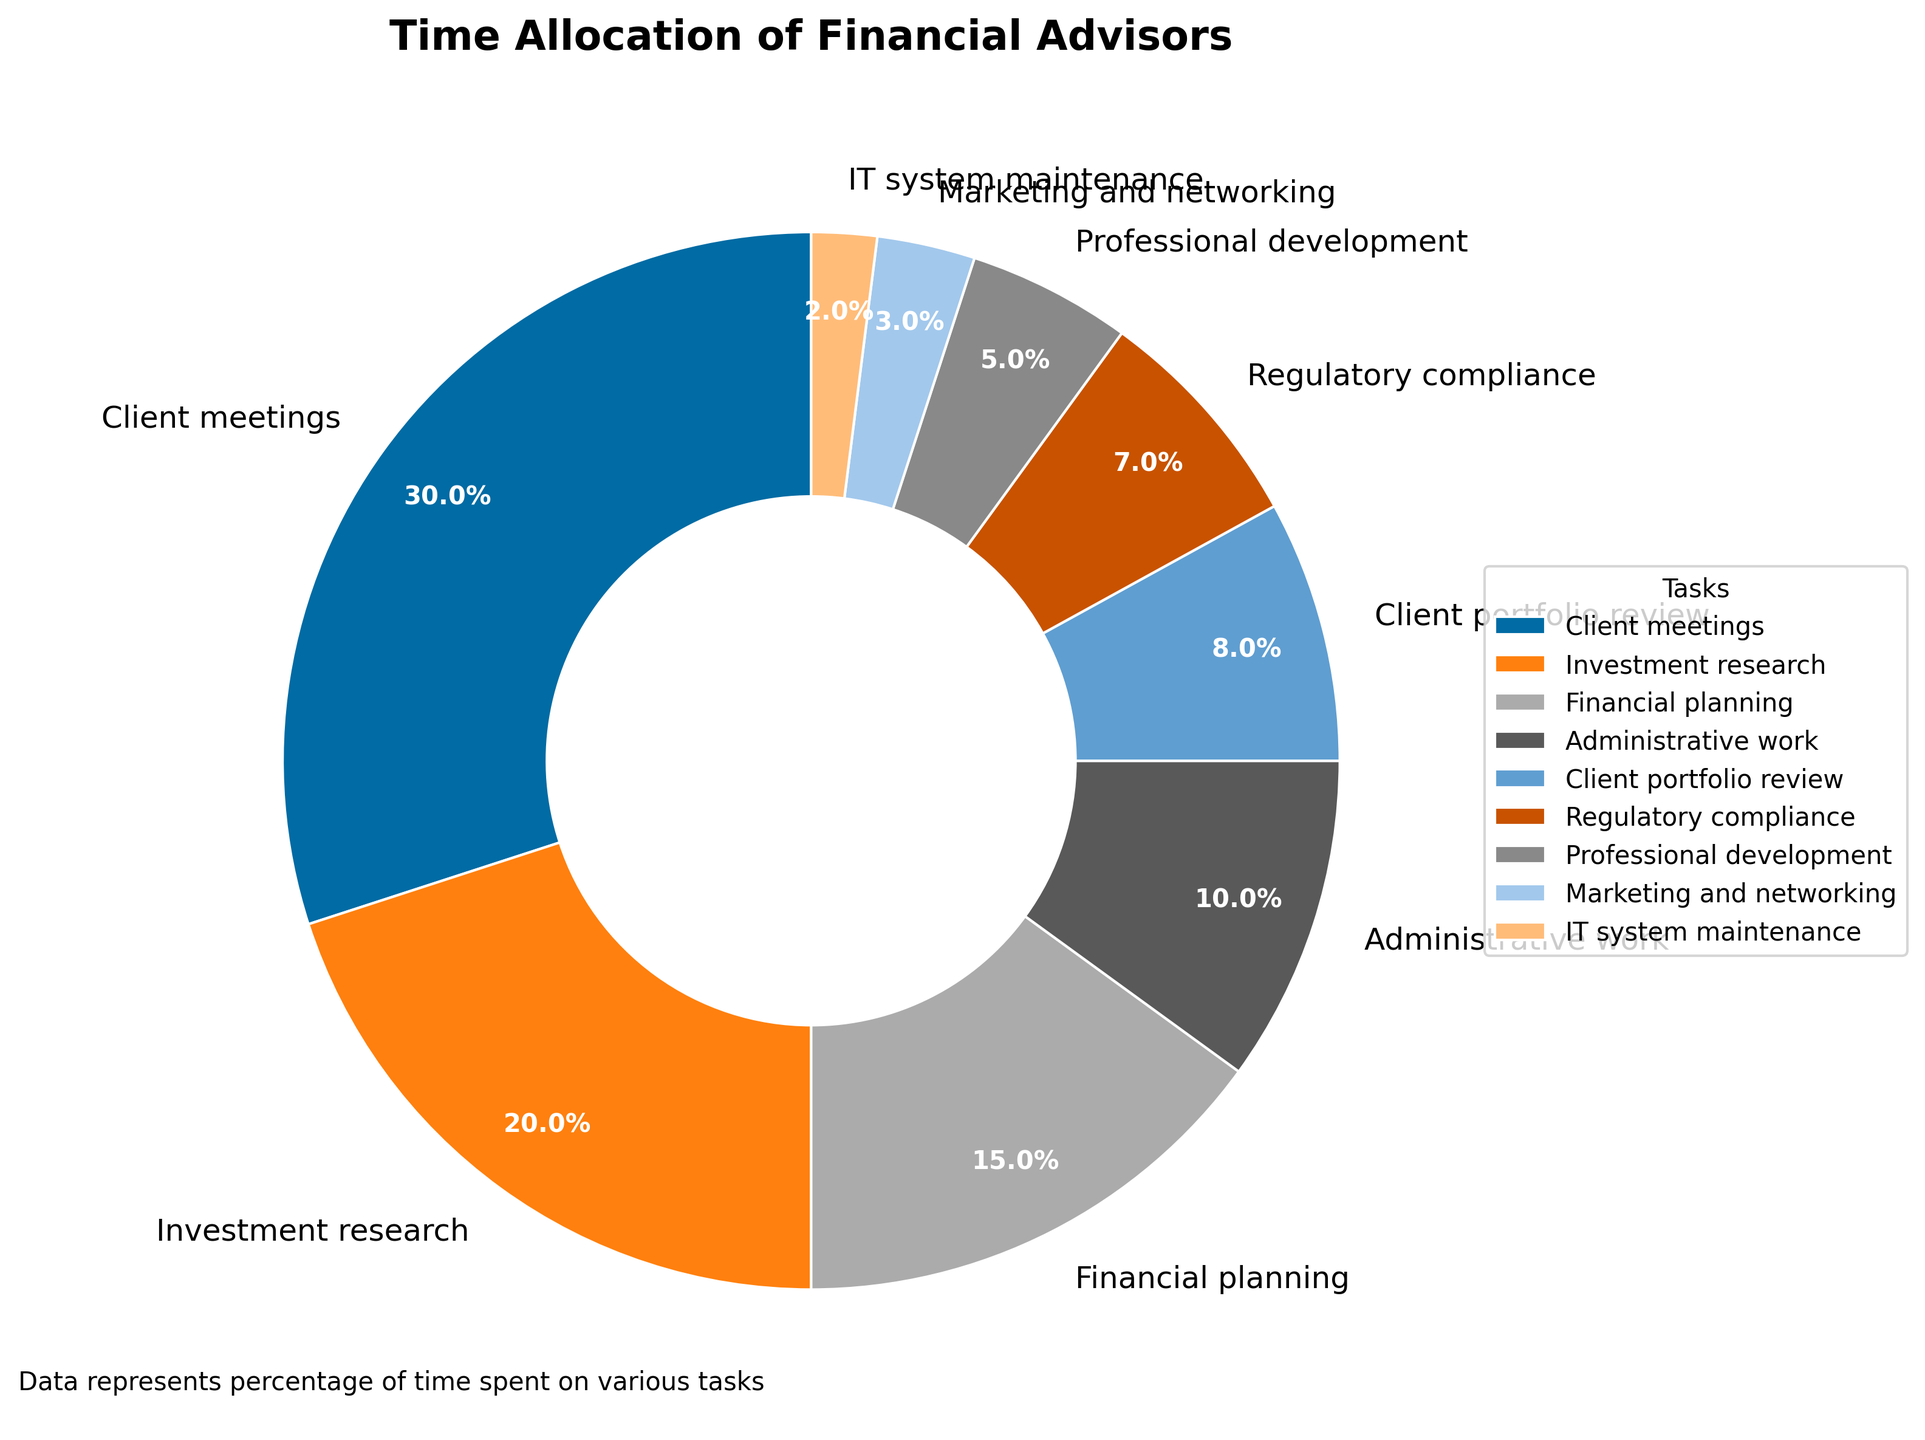What percentage of time is allocated to client meetings? Locate the "Client meetings" segment on the pie chart, which shows the percentage value inside it.
Answer: 30% How much more time is spent on client meetings compared to administrative work? Find the percentages for "Client meetings" (30%) and "Administrative work" (10%). Subtract the smaller from the larger (30% - 10%).
Answer: 20% Which task takes up the least amount of time? Identify the smallest segment on the pie chart. The smallest segment is for "IT system maintenance".
Answer: IT system maintenance What is the combined percentage of time spent on investment research and financial planning? Find the percentages for "Investment research" (20%) and "Financial planning" (15%). Add them together (20% + 15%).
Answer: 35% How does the time allocated to marketing and networking compare to time spent on regulatory compliance? Find the percentages for "Marketing and networking" (3%) and "Regulatory compliance" (7%). Compare the two values. 7% is greater than 3%.
Answer: Regulatory compliance is more Which task occupies a greater percentage of time: client portfolio review or professional development? Locate the segments for "Client portfolio review" (8%) and "Professional development" (5%). Compare the two values—8% is greater than 5%.
Answer: Client portfolio review What is the difference in time allocation between the most and least time-consuming tasks? The most time-consuming task is "Client meetings" (30%) and the least is "IT system maintenance" (2%). Subtract the smallest from the largest (30% - 2%).
Answer: 28% What tasks form the middle tier in terms of time allocation? Order tasks by percentage and find the middle. Middle tasks are "Financial planning" (15%), "Administrative work" (10%), and "Client portfolio review" (8%).
Answer: Financial planning, Administrative work, Client portfolio review If you combine time spent on administrative work and IT system maintenance, does it exceed the time spent on professional development? Find the percentages for "Administrative work" (10%) and "IT system maintenance" (2%). Add them (10% + 2% = 12%) and compare with "Professional development" (5%). 12% is greater than 5%.
Answer: Yes Which task has a larger allocation: investment research or marketing and networking? Locate segments for "Investment research" (20%) and "Marketing and networking" (3%). Compare the two values—20% is greater than 3%.
Answer: Investment research 